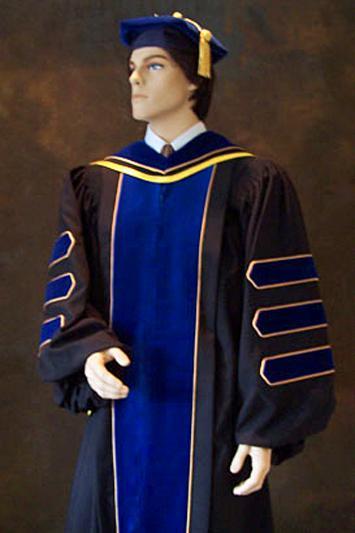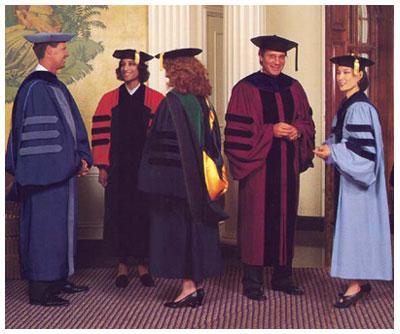The first image is the image on the left, the second image is the image on the right. Examine the images to the left and right. Is the description "There is one guy in the left image, wearing a black robe with blue stripes on the sleeve." accurate? Answer yes or no. Yes. 